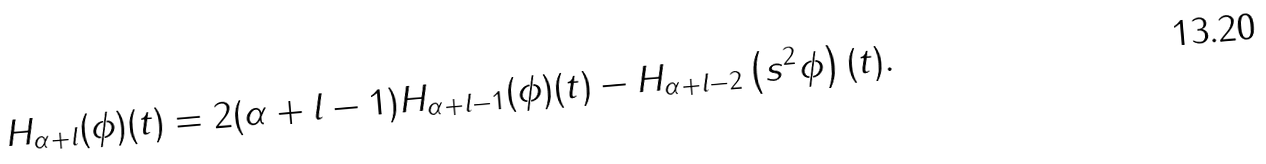Convert formula to latex. <formula><loc_0><loc_0><loc_500><loc_500>H _ { \alpha + l } ( \phi ) ( t ) = 2 ( \alpha + l - 1 ) H _ { \alpha + l - 1 } ( \phi ) ( t ) - H _ { \alpha + l - 2 } \left ( s ^ { 2 } \phi \right ) ( t ) .</formula> 